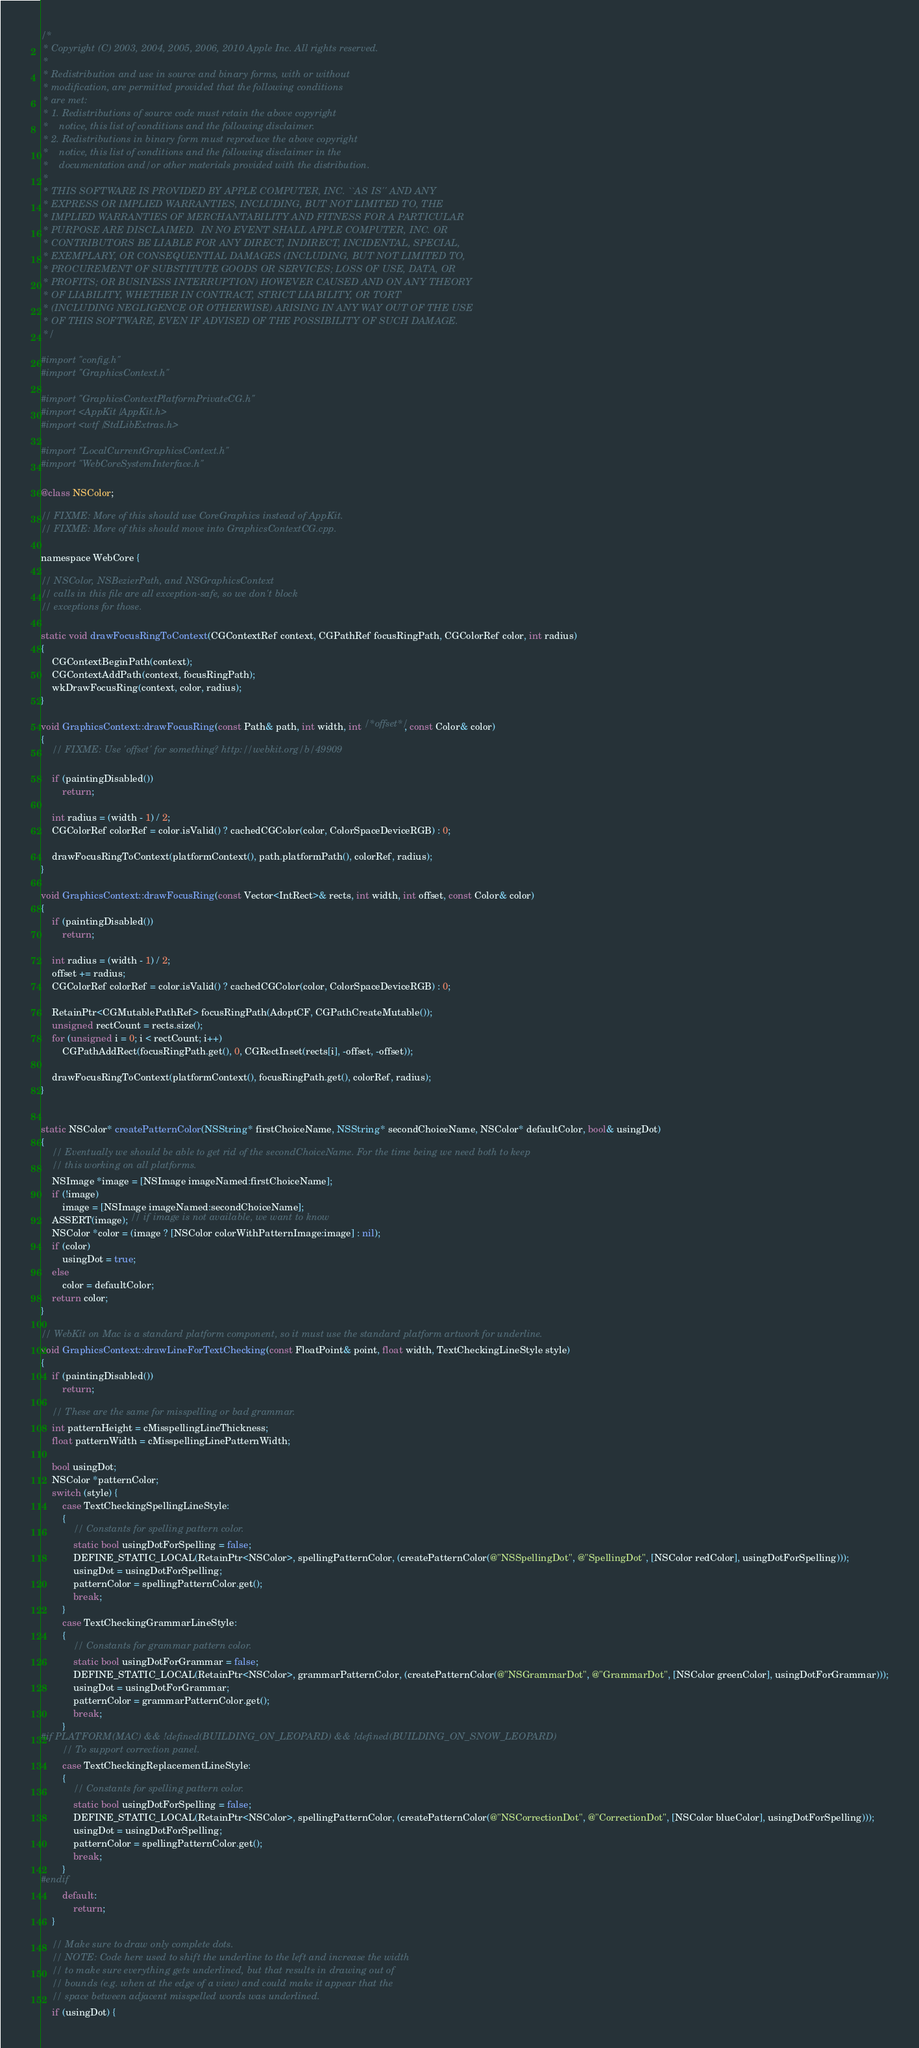<code> <loc_0><loc_0><loc_500><loc_500><_ObjectiveC_>/*
 * Copyright (C) 2003, 2004, 2005, 2006, 2010 Apple Inc. All rights reserved.
 *
 * Redistribution and use in source and binary forms, with or without
 * modification, are permitted provided that the following conditions
 * are met:
 * 1. Redistributions of source code must retain the above copyright
 *    notice, this list of conditions and the following disclaimer.
 * 2. Redistributions in binary form must reproduce the above copyright
 *    notice, this list of conditions and the following disclaimer in the
 *    documentation and/or other materials provided with the distribution.
 *
 * THIS SOFTWARE IS PROVIDED BY APPLE COMPUTER, INC. ``AS IS'' AND ANY
 * EXPRESS OR IMPLIED WARRANTIES, INCLUDING, BUT NOT LIMITED TO, THE
 * IMPLIED WARRANTIES OF MERCHANTABILITY AND FITNESS FOR A PARTICULAR
 * PURPOSE ARE DISCLAIMED.  IN NO EVENT SHALL APPLE COMPUTER, INC. OR
 * CONTRIBUTORS BE LIABLE FOR ANY DIRECT, INDIRECT, INCIDENTAL, SPECIAL,
 * EXEMPLARY, OR CONSEQUENTIAL DAMAGES (INCLUDING, BUT NOT LIMITED TO,
 * PROCUREMENT OF SUBSTITUTE GOODS OR SERVICES; LOSS OF USE, DATA, OR
 * PROFITS; OR BUSINESS INTERRUPTION) HOWEVER CAUSED AND ON ANY THEORY
 * OF LIABILITY, WHETHER IN CONTRACT, STRICT LIABILITY, OR TORT
 * (INCLUDING NEGLIGENCE OR OTHERWISE) ARISING IN ANY WAY OUT OF THE USE
 * OF THIS SOFTWARE, EVEN IF ADVISED OF THE POSSIBILITY OF SUCH DAMAGE. 
 */

#import "config.h"
#import "GraphicsContext.h"

#import "GraphicsContextPlatformPrivateCG.h"
#import <AppKit/AppKit.h>
#import <wtf/StdLibExtras.h>

#import "LocalCurrentGraphicsContext.h"
#import "WebCoreSystemInterface.h"

@class NSColor;

// FIXME: More of this should use CoreGraphics instead of AppKit.
// FIXME: More of this should move into GraphicsContextCG.cpp.

namespace WebCore {

// NSColor, NSBezierPath, and NSGraphicsContext
// calls in this file are all exception-safe, so we don't block
// exceptions for those.

static void drawFocusRingToContext(CGContextRef context, CGPathRef focusRingPath, CGColorRef color, int radius)
{
    CGContextBeginPath(context);
    CGContextAddPath(context, focusRingPath);
    wkDrawFocusRing(context, color, radius);
}

void GraphicsContext::drawFocusRing(const Path& path, int width, int /*offset*/, const Color& color)
{
    // FIXME: Use 'offset' for something? http://webkit.org/b/49909

    if (paintingDisabled())
        return;

    int radius = (width - 1) / 2;
    CGColorRef colorRef = color.isValid() ? cachedCGColor(color, ColorSpaceDeviceRGB) : 0;

    drawFocusRingToContext(platformContext(), path.platformPath(), colorRef, radius);
}

void GraphicsContext::drawFocusRing(const Vector<IntRect>& rects, int width, int offset, const Color& color)
{
    if (paintingDisabled())
        return;

    int radius = (width - 1) / 2;
    offset += radius;
    CGColorRef colorRef = color.isValid() ? cachedCGColor(color, ColorSpaceDeviceRGB) : 0;

    RetainPtr<CGMutablePathRef> focusRingPath(AdoptCF, CGPathCreateMutable());
    unsigned rectCount = rects.size();
    for (unsigned i = 0; i < rectCount; i++)
        CGPathAddRect(focusRingPath.get(), 0, CGRectInset(rects[i], -offset, -offset));

    drawFocusRingToContext(platformContext(), focusRingPath.get(), colorRef, radius);
}


static NSColor* createPatternColor(NSString* firstChoiceName, NSString* secondChoiceName, NSColor* defaultColor, bool& usingDot)
{
    // Eventually we should be able to get rid of the secondChoiceName. For the time being we need both to keep
    // this working on all platforms.
    NSImage *image = [NSImage imageNamed:firstChoiceName];
    if (!image)
        image = [NSImage imageNamed:secondChoiceName];
    ASSERT(image); // if image is not available, we want to know
    NSColor *color = (image ? [NSColor colorWithPatternImage:image] : nil);
    if (color)
        usingDot = true;
    else
        color = defaultColor;
    return color;
}

// WebKit on Mac is a standard platform component, so it must use the standard platform artwork for underline.
void GraphicsContext::drawLineForTextChecking(const FloatPoint& point, float width, TextCheckingLineStyle style)
{
    if (paintingDisabled())
        return;
        
    // These are the same for misspelling or bad grammar.
    int patternHeight = cMisspellingLineThickness;
    float patternWidth = cMisspellingLinePatternWidth;

    bool usingDot;
    NSColor *patternColor;
    switch (style) {
        case TextCheckingSpellingLineStyle:
        {
            // Constants for spelling pattern color.
            static bool usingDotForSpelling = false;
            DEFINE_STATIC_LOCAL(RetainPtr<NSColor>, spellingPatternColor, (createPatternColor(@"NSSpellingDot", @"SpellingDot", [NSColor redColor], usingDotForSpelling)));
            usingDot = usingDotForSpelling;
            patternColor = spellingPatternColor.get();
            break;
        }
        case TextCheckingGrammarLineStyle:
        {
            // Constants for grammar pattern color.
            static bool usingDotForGrammar = false;
            DEFINE_STATIC_LOCAL(RetainPtr<NSColor>, grammarPatternColor, (createPatternColor(@"NSGrammarDot", @"GrammarDot", [NSColor greenColor], usingDotForGrammar)));
            usingDot = usingDotForGrammar;
            patternColor = grammarPatternColor.get();
            break;
        }
#if PLATFORM(MAC) && !defined(BUILDING_ON_LEOPARD) && !defined(BUILDING_ON_SNOW_LEOPARD)
        // To support correction panel.
        case TextCheckingReplacementLineStyle:
        {
            // Constants for spelling pattern color.
            static bool usingDotForSpelling = false;
            DEFINE_STATIC_LOCAL(RetainPtr<NSColor>, spellingPatternColor, (createPatternColor(@"NSCorrectionDot", @"CorrectionDot", [NSColor blueColor], usingDotForSpelling)));
            usingDot = usingDotForSpelling;
            patternColor = spellingPatternColor.get();
            break;
        }
#endif
        default:
            return;
    }

    // Make sure to draw only complete dots.
    // NOTE: Code here used to shift the underline to the left and increase the width
    // to make sure everything gets underlined, but that results in drawing out of
    // bounds (e.g. when at the edge of a view) and could make it appear that the
    // space between adjacent misspelled words was underlined.
    if (usingDot) {</code> 